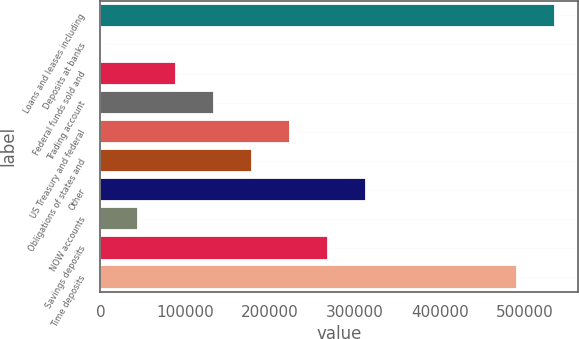<chart> <loc_0><loc_0><loc_500><loc_500><bar_chart><fcel>Loans and leases including<fcel>Deposits at banks<fcel>Federal funds sold and<fcel>Trading account<fcel>US Treasury and federal<fcel>Obligations of states and<fcel>Other<fcel>NOW accounts<fcel>Savings deposits<fcel>Time deposits<nl><fcel>536094<fcel>104<fcel>89435.6<fcel>134101<fcel>223433<fcel>178767<fcel>312765<fcel>44769.8<fcel>268099<fcel>491428<nl></chart> 